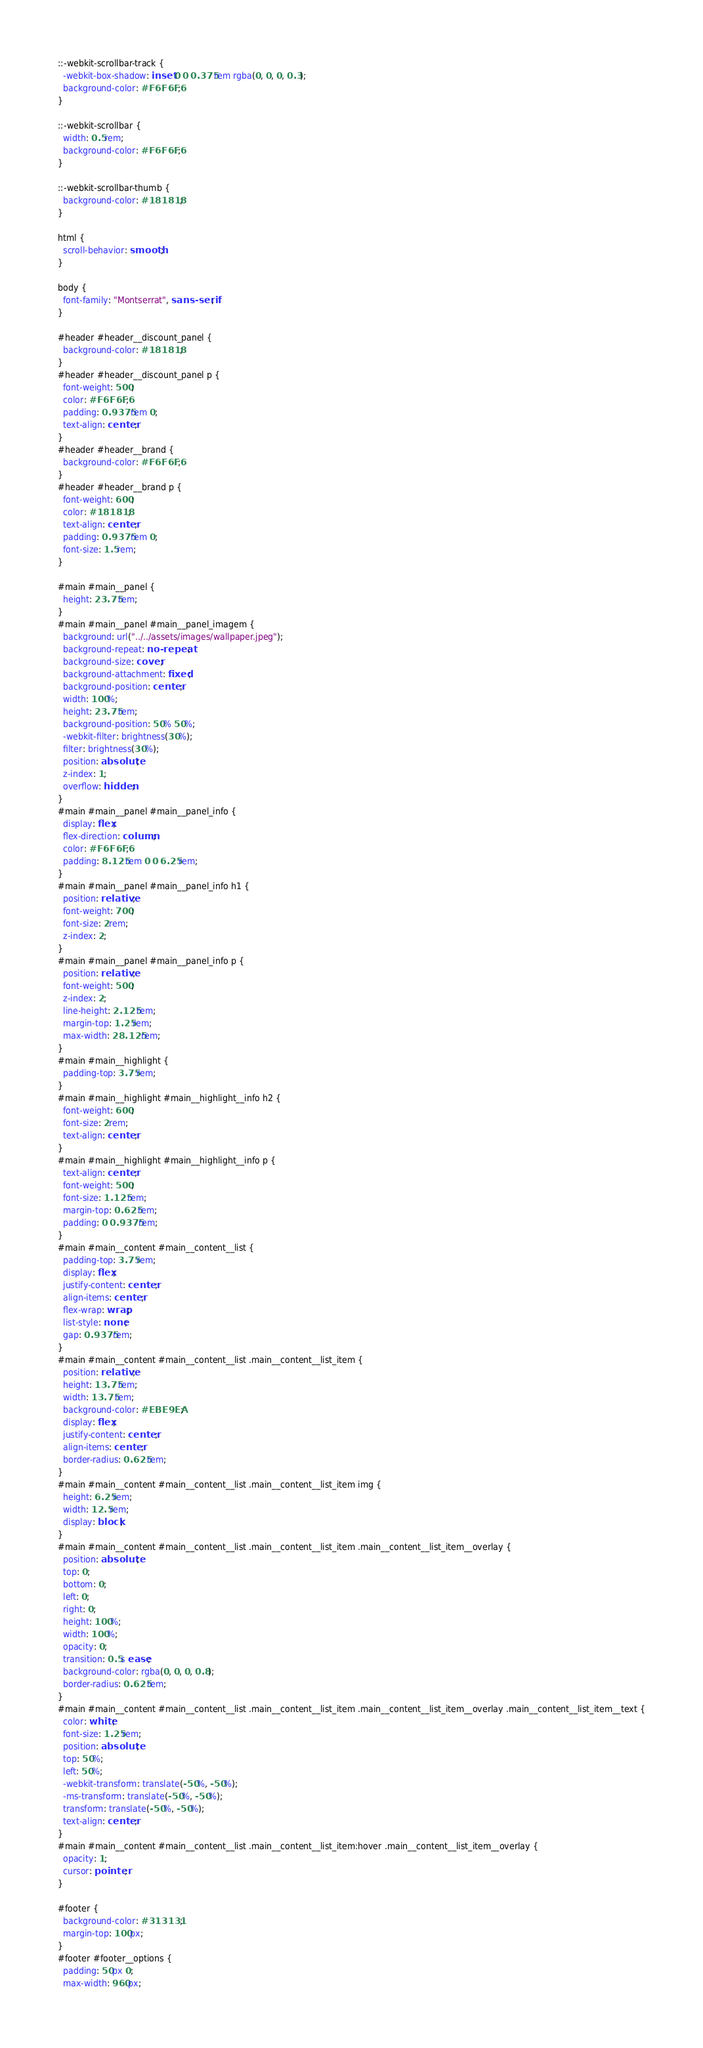Convert code to text. <code><loc_0><loc_0><loc_500><loc_500><_CSS_>::-webkit-scrollbar-track {
  -webkit-box-shadow: inset 0 0 0.375rem rgba(0, 0, 0, 0.3);
  background-color: #F6F6F6;
}

::-webkit-scrollbar {
  width: 0.5rem;
  background-color: #F6F6F6;
}

::-webkit-scrollbar-thumb {
  background-color: #181818;
}

html {
  scroll-behavior: smooth;
}

body {
  font-family: "Montserrat", sans-serif;
}

#header #header__discount_panel {
  background-color: #181818;
}
#header #header__discount_panel p {
  font-weight: 500;
  color: #F6F6F6;
  padding: 0.9375rem 0;
  text-align: center;
}
#header #header__brand {
  background-color: #F6F6F6;
}
#header #header__brand p {
  font-weight: 600;
  color: #181818;
  text-align: center;
  padding: 0.9375rem 0;
  font-size: 1.5rem;
}

#main #main__panel {
  height: 23.75rem;
}
#main #main__panel #main__panel_imagem {
  background: url("../../assets/images/wallpaper.jpeg");
  background-repeat: no-repeat;
  background-size: cover;
  background-attachment: fixed;
  background-position: center;
  width: 100%;
  height: 23.75rem;
  background-position: 50% 50%;
  -webkit-filter: brightness(30%);
  filter: brightness(30%);
  position: absolute;
  z-index: 1;
  overflow: hidden;
}
#main #main__panel #main__panel_info {
  display: flex;
  flex-direction: column;
  color: #F6F6F6;
  padding: 8.125rem 0 0 6.25rem;
}
#main #main__panel #main__panel_info h1 {
  position: relative;
  font-weight: 700;
  font-size: 2rem;
  z-index: 2;
}
#main #main__panel #main__panel_info p {
  position: relative;
  font-weight: 500;
  z-index: 2;
  line-height: 2.125rem;
  margin-top: 1.25rem;
  max-width: 28.125rem;
}
#main #main__highlight {
  padding-top: 3.75rem;
}
#main #main__highlight #main__highlight__info h2 {
  font-weight: 600;
  font-size: 2rem;
  text-align: center;
}
#main #main__highlight #main__highlight__info p {
  text-align: center;
  font-weight: 500;
  font-size: 1.125rem;
  margin-top: 0.625rem;
  padding: 0 0.9375rem;
}
#main #main__content #main__content__list {
  padding-top: 3.75rem;
  display: flex;
  justify-content: center;
  align-items: center;
  flex-wrap: wrap;
  list-style: none;
  gap: 0.9375rem;
}
#main #main__content #main__content__list .main__content__list_item {
  position: relative;
  height: 13.75rem;
  width: 13.75rem;
  background-color: #EBE9EA;
  display: flex;
  justify-content: center;
  align-items: center;
  border-radius: 0.625rem;
}
#main #main__content #main__content__list .main__content__list_item img {
  height: 6.25rem;
  width: 12.5rem;
  display: block;
}
#main #main__content #main__content__list .main__content__list_item .main__content__list_item__overlay {
  position: absolute;
  top: 0;
  bottom: 0;
  left: 0;
  right: 0;
  height: 100%;
  width: 100%;
  opacity: 0;
  transition: 0.5s ease;
  background-color: rgba(0, 0, 0, 0.8);
  border-radius: 0.625rem;
}
#main #main__content #main__content__list .main__content__list_item .main__content__list_item__overlay .main__content__list_item__text {
  color: white;
  font-size: 1.25rem;
  position: absolute;
  top: 50%;
  left: 50%;
  -webkit-transform: translate(-50%, -50%);
  -ms-transform: translate(-50%, -50%);
  transform: translate(-50%, -50%);
  text-align: center;
}
#main #main__content #main__content__list .main__content__list_item:hover .main__content__list_item__overlay {
  opacity: 1;
  cursor: pointer;
}

#footer {
  background-color: #313131;
  margin-top: 100px;
}
#footer #footer__options {
  padding: 50px 0;
  max-width: 960px;</code> 